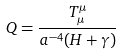<formula> <loc_0><loc_0><loc_500><loc_500>Q = \frac { T ^ { \mu } _ { \mu } } { a ^ { - 4 } ( H + \gamma ) }</formula> 